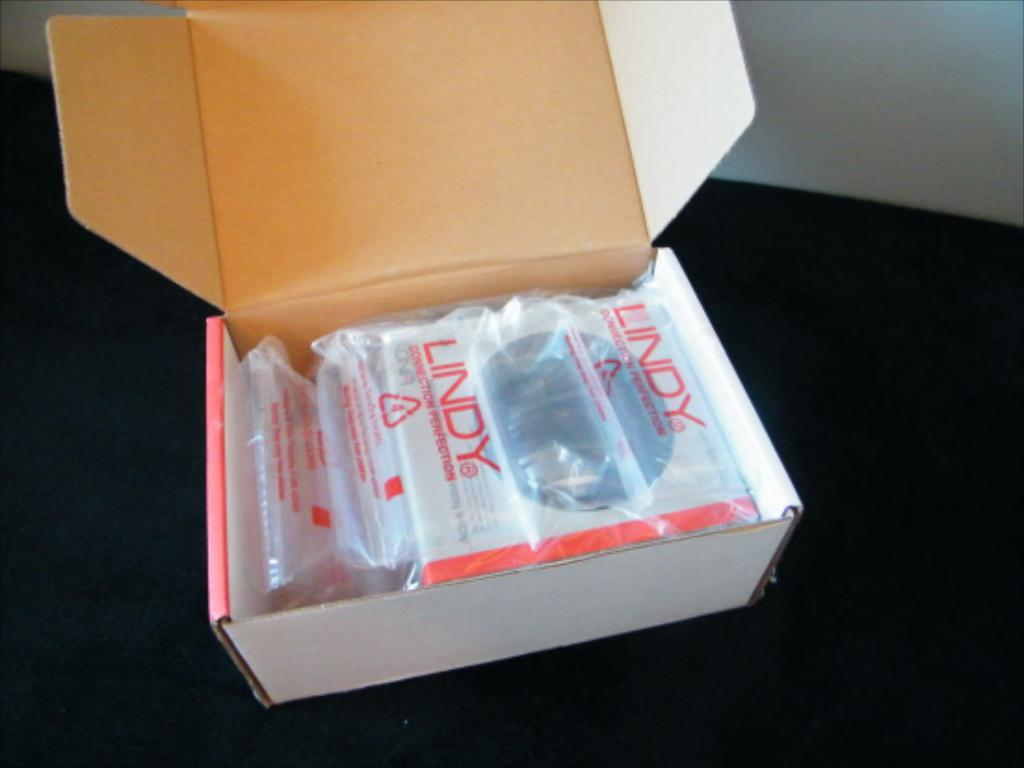<image>
Create a compact narrative representing the image presented. An opened cardboard box with a Lindy package inside. 